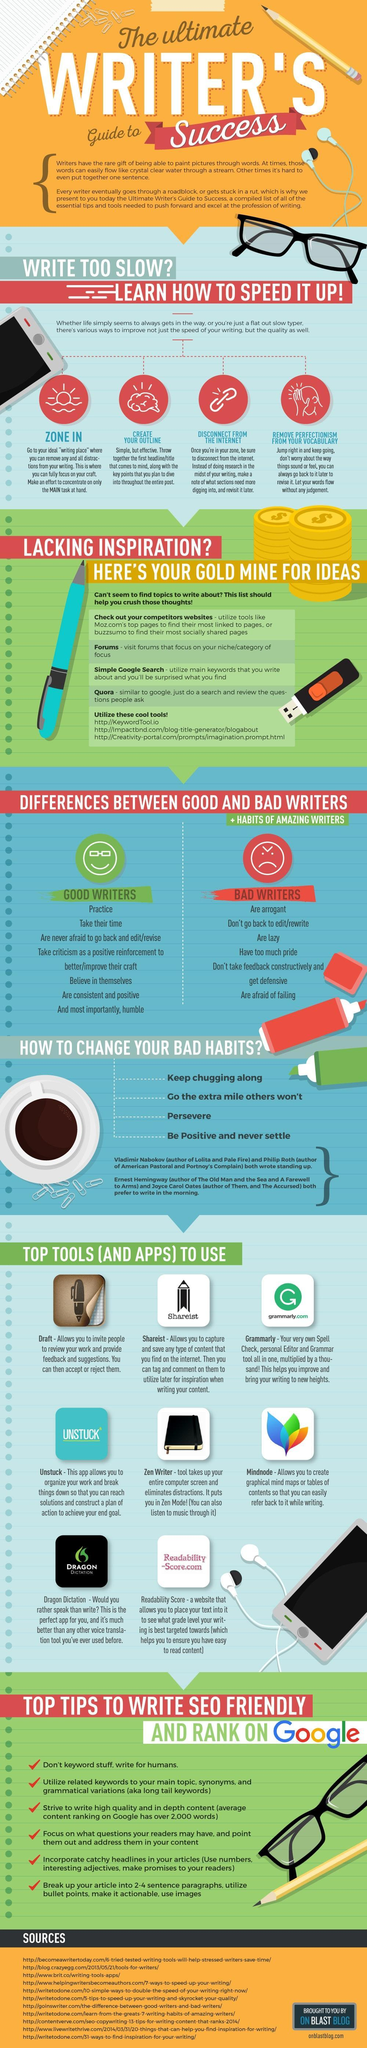How many paper clips are shown in the infographic?
Answer the question with a short phrase. 14 How many top tools and apps are listed? 8 How many sources are listed at the bottom? 11 